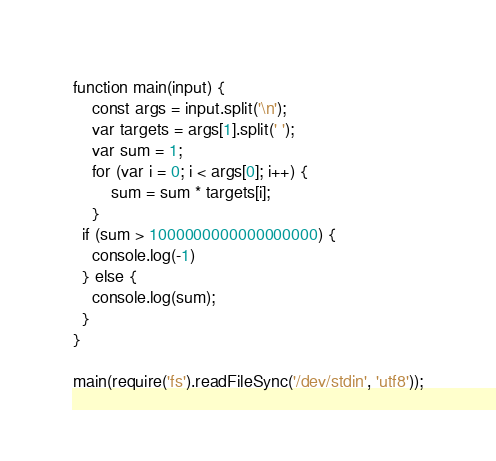<code> <loc_0><loc_0><loc_500><loc_500><_JavaScript_>function main(input) {
    const args = input.split('\n');
  	var targets = args[1].split(' ');
  	var sum = 1;
    for (var i = 0; i < args[0]; i++) {
    	sum = sum * targets[i];
    }
  if (sum > 1000000000000000000) {
    console.log(-1)
  } else {
  	console.log(sum);
  }
}

main(require('fs').readFileSync('/dev/stdin', 'utf8'));</code> 